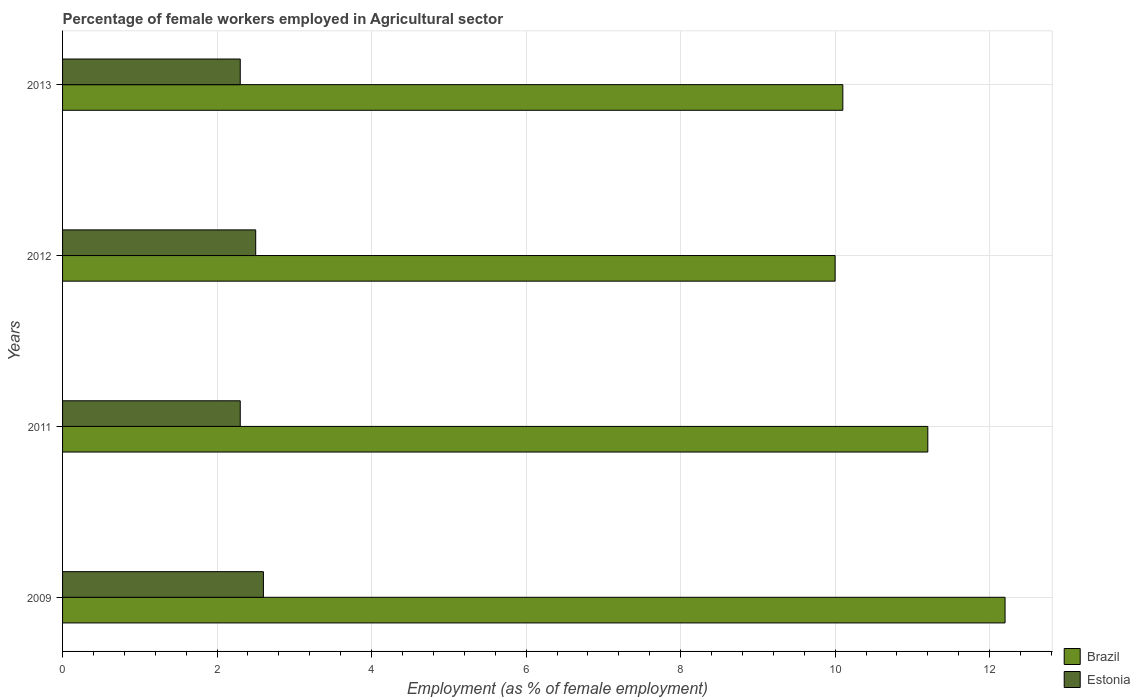How many groups of bars are there?
Ensure brevity in your answer.  4. Are the number of bars on each tick of the Y-axis equal?
Your answer should be compact. Yes. In how many cases, is the number of bars for a given year not equal to the number of legend labels?
Your response must be concise. 0. What is the percentage of females employed in Agricultural sector in Estonia in 2013?
Provide a succinct answer. 2.3. Across all years, what is the maximum percentage of females employed in Agricultural sector in Estonia?
Offer a terse response. 2.6. In which year was the percentage of females employed in Agricultural sector in Brazil maximum?
Provide a succinct answer. 2009. In which year was the percentage of females employed in Agricultural sector in Brazil minimum?
Offer a terse response. 2012. What is the total percentage of females employed in Agricultural sector in Estonia in the graph?
Give a very brief answer. 9.7. What is the difference between the percentage of females employed in Agricultural sector in Estonia in 2011 and that in 2013?
Give a very brief answer. 0. What is the difference between the percentage of females employed in Agricultural sector in Brazil in 2009 and the percentage of females employed in Agricultural sector in Estonia in 2013?
Make the answer very short. 9.9. What is the average percentage of females employed in Agricultural sector in Brazil per year?
Ensure brevity in your answer.  10.87. In the year 2012, what is the difference between the percentage of females employed in Agricultural sector in Estonia and percentage of females employed in Agricultural sector in Brazil?
Your response must be concise. -7.5. What is the ratio of the percentage of females employed in Agricultural sector in Brazil in 2009 to that in 2012?
Offer a terse response. 1.22. Is the percentage of females employed in Agricultural sector in Brazil in 2012 less than that in 2013?
Provide a short and direct response. Yes. What is the difference between the highest and the lowest percentage of females employed in Agricultural sector in Estonia?
Keep it short and to the point. 0.3. What does the 1st bar from the top in 2013 represents?
Provide a short and direct response. Estonia. What does the 2nd bar from the bottom in 2013 represents?
Provide a short and direct response. Estonia. How many bars are there?
Make the answer very short. 8. Are all the bars in the graph horizontal?
Your answer should be very brief. Yes. Does the graph contain grids?
Offer a terse response. Yes. Where does the legend appear in the graph?
Make the answer very short. Bottom right. What is the title of the graph?
Your answer should be compact. Percentage of female workers employed in Agricultural sector. Does "Costa Rica" appear as one of the legend labels in the graph?
Offer a very short reply. No. What is the label or title of the X-axis?
Keep it short and to the point. Employment (as % of female employment). What is the label or title of the Y-axis?
Offer a very short reply. Years. What is the Employment (as % of female employment) in Brazil in 2009?
Keep it short and to the point. 12.2. What is the Employment (as % of female employment) of Estonia in 2009?
Your response must be concise. 2.6. What is the Employment (as % of female employment) of Brazil in 2011?
Provide a succinct answer. 11.2. What is the Employment (as % of female employment) in Estonia in 2011?
Keep it short and to the point. 2.3. What is the Employment (as % of female employment) of Brazil in 2013?
Your answer should be very brief. 10.1. What is the Employment (as % of female employment) of Estonia in 2013?
Offer a very short reply. 2.3. Across all years, what is the maximum Employment (as % of female employment) in Brazil?
Provide a short and direct response. 12.2. Across all years, what is the maximum Employment (as % of female employment) of Estonia?
Keep it short and to the point. 2.6. Across all years, what is the minimum Employment (as % of female employment) in Estonia?
Give a very brief answer. 2.3. What is the total Employment (as % of female employment) of Brazil in the graph?
Your answer should be compact. 43.5. What is the difference between the Employment (as % of female employment) of Brazil in 2009 and that in 2012?
Make the answer very short. 2.2. What is the difference between the Employment (as % of female employment) in Estonia in 2009 and that in 2012?
Make the answer very short. 0.1. What is the difference between the Employment (as % of female employment) of Brazil in 2009 and that in 2013?
Offer a terse response. 2.1. What is the difference between the Employment (as % of female employment) in Estonia in 2009 and that in 2013?
Provide a succinct answer. 0.3. What is the difference between the Employment (as % of female employment) of Brazil in 2011 and that in 2012?
Make the answer very short. 1.2. What is the difference between the Employment (as % of female employment) of Brazil in 2012 and that in 2013?
Your response must be concise. -0.1. What is the difference between the Employment (as % of female employment) in Brazil in 2009 and the Employment (as % of female employment) in Estonia in 2013?
Offer a terse response. 9.9. What is the difference between the Employment (as % of female employment) in Brazil in 2011 and the Employment (as % of female employment) in Estonia in 2012?
Your answer should be very brief. 8.7. What is the average Employment (as % of female employment) of Brazil per year?
Provide a short and direct response. 10.88. What is the average Employment (as % of female employment) in Estonia per year?
Give a very brief answer. 2.42. In the year 2009, what is the difference between the Employment (as % of female employment) of Brazil and Employment (as % of female employment) of Estonia?
Offer a very short reply. 9.6. In the year 2012, what is the difference between the Employment (as % of female employment) of Brazil and Employment (as % of female employment) of Estonia?
Keep it short and to the point. 7.5. In the year 2013, what is the difference between the Employment (as % of female employment) in Brazil and Employment (as % of female employment) in Estonia?
Your answer should be very brief. 7.8. What is the ratio of the Employment (as % of female employment) of Brazil in 2009 to that in 2011?
Keep it short and to the point. 1.09. What is the ratio of the Employment (as % of female employment) of Estonia in 2009 to that in 2011?
Ensure brevity in your answer.  1.13. What is the ratio of the Employment (as % of female employment) of Brazil in 2009 to that in 2012?
Your answer should be very brief. 1.22. What is the ratio of the Employment (as % of female employment) of Estonia in 2009 to that in 2012?
Offer a very short reply. 1.04. What is the ratio of the Employment (as % of female employment) of Brazil in 2009 to that in 2013?
Your response must be concise. 1.21. What is the ratio of the Employment (as % of female employment) in Estonia in 2009 to that in 2013?
Offer a very short reply. 1.13. What is the ratio of the Employment (as % of female employment) of Brazil in 2011 to that in 2012?
Give a very brief answer. 1.12. What is the ratio of the Employment (as % of female employment) in Estonia in 2011 to that in 2012?
Keep it short and to the point. 0.92. What is the ratio of the Employment (as % of female employment) in Brazil in 2011 to that in 2013?
Your answer should be very brief. 1.11. What is the ratio of the Employment (as % of female employment) in Estonia in 2012 to that in 2013?
Your response must be concise. 1.09. What is the difference between the highest and the lowest Employment (as % of female employment) in Brazil?
Your answer should be compact. 2.2. What is the difference between the highest and the lowest Employment (as % of female employment) in Estonia?
Your answer should be very brief. 0.3. 